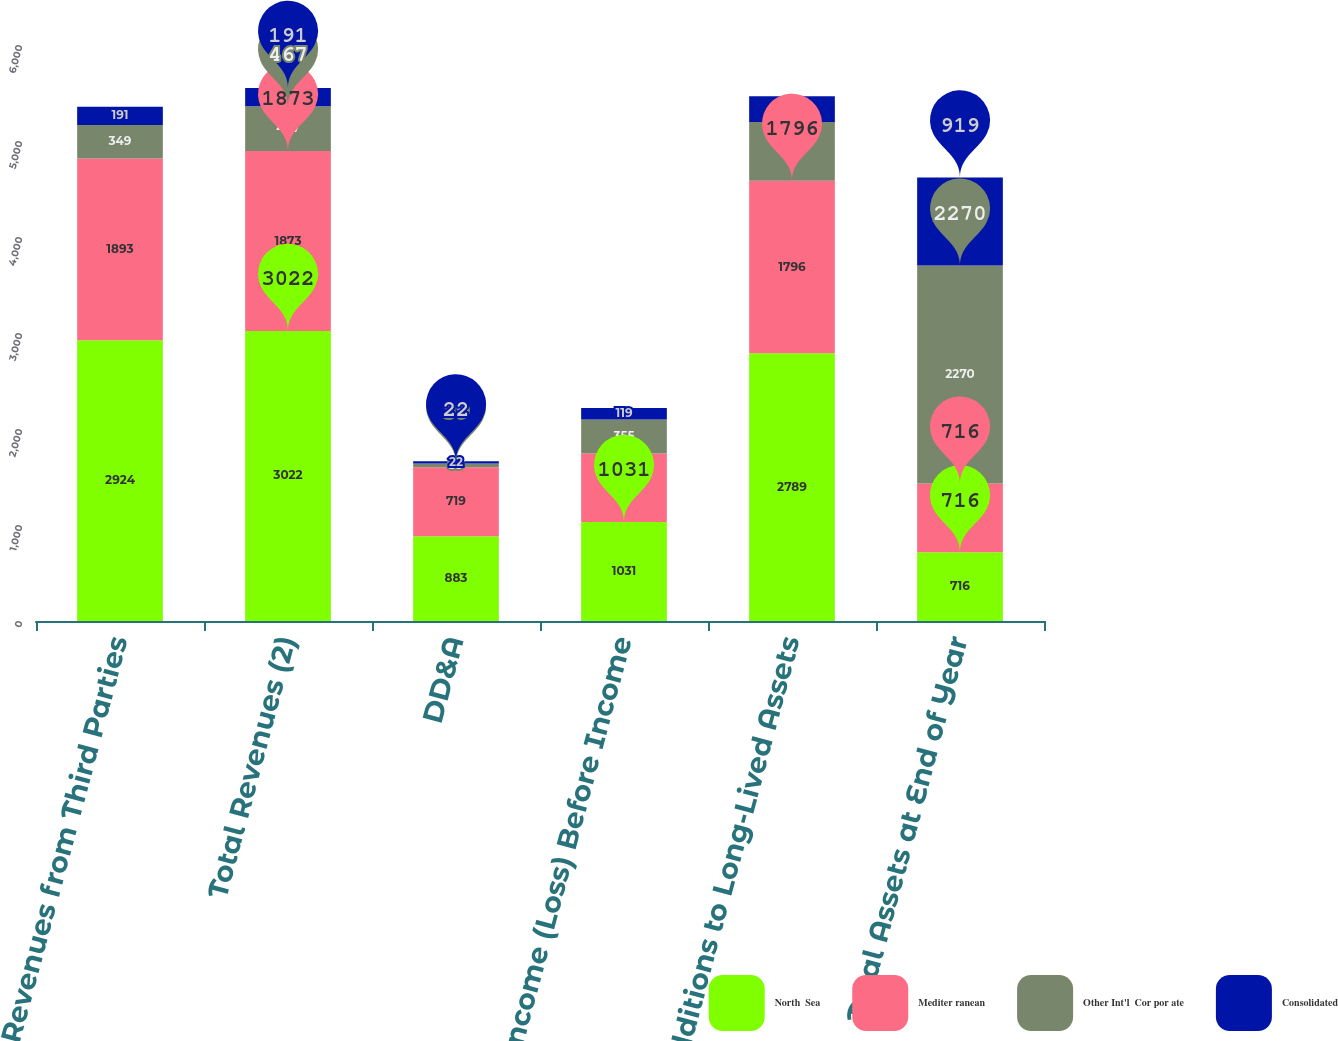Convert chart to OTSL. <chart><loc_0><loc_0><loc_500><loc_500><stacked_bar_chart><ecel><fcel>Revenues from Third Parties<fcel>Total Revenues (2)<fcel>DD&A<fcel>Income (Loss) Before Income<fcel>Additions to Long-Lived Assets<fcel>Total Assets at End of Year<nl><fcel>North  Sea<fcel>2924<fcel>3022<fcel>883<fcel>1031<fcel>2789<fcel>716<nl><fcel>Mediter ranean<fcel>1893<fcel>1873<fcel>719<fcel>713<fcel>1796<fcel>716<nl><fcel>Other Int'l  Cor por ate<fcel>349<fcel>467<fcel>39<fcel>355<fcel>612<fcel>2270<nl><fcel>Consolidated<fcel>191<fcel>191<fcel>22<fcel>119<fcel>270<fcel>919<nl></chart> 